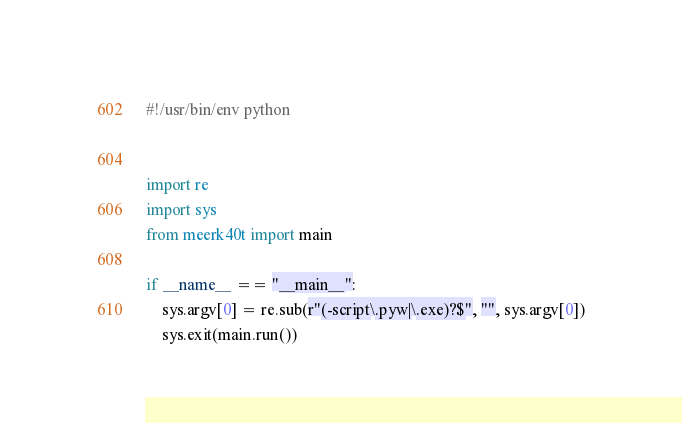Convert code to text. <code><loc_0><loc_0><loc_500><loc_500><_Python_>#!/usr/bin/env python


import re
import sys
from meerk40t import main

if __name__ == "__main__":
    sys.argv[0] = re.sub(r"(-script\.pyw|\.exe)?$", "", sys.argv[0])
    sys.exit(main.run())
</code> 